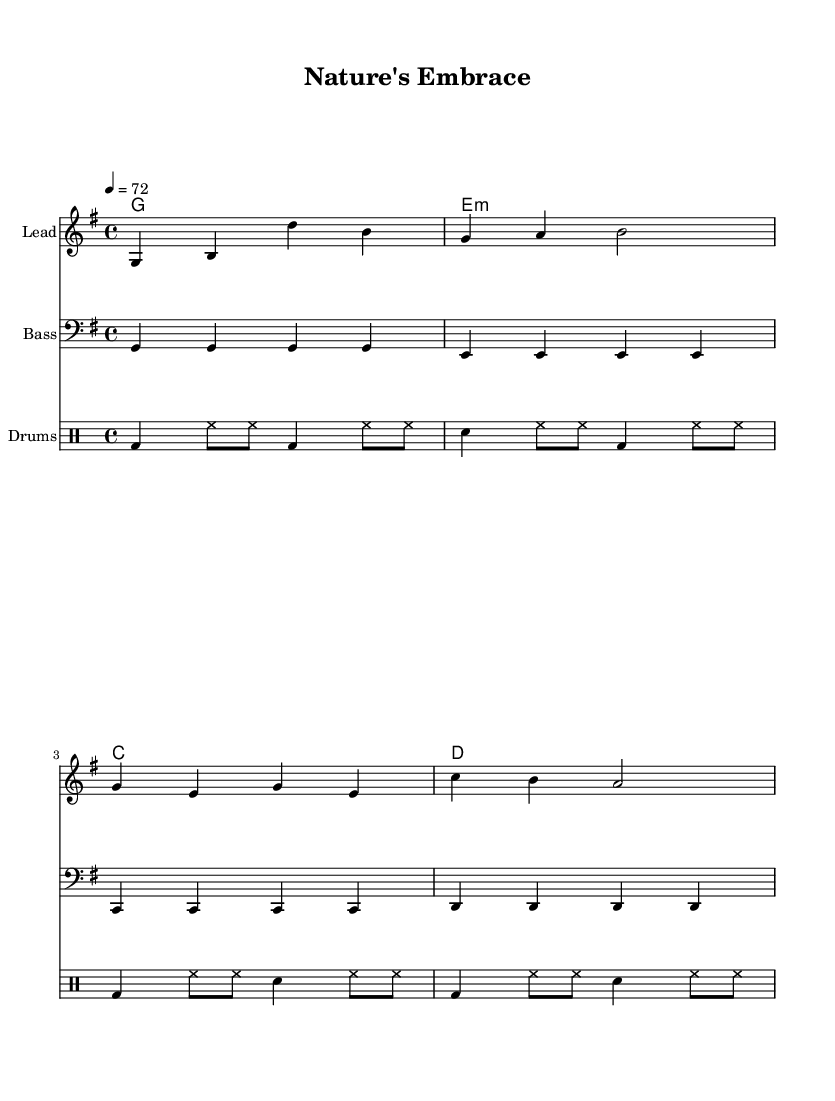What is the key signature of this music? The key signature is G major, which has one sharp (F#). This can be identified by looking at the key signature indicated at the beginning of the staff where the note F has a sharp symbol.
Answer: G major What is the time signature of this piece? The time signature is 4/4, which means there are four beats in each measure and the quarter note gets one beat. This is stated at the beginning of the score where the "4/4" is written.
Answer: 4/4 What is the tempo marking for this piece? The tempo marking is 72 beats per minute. It is indicated at the beginning of the score with the note "4 = 72," meaning a quarter note gets 72 beats in one minute.
Answer: 72 How many measures are in the melody? The melody consists of four measures. This can be counted by looking at the vertical bar lines separating each measure in the melody's notation.
Answer: 4 What chord is played on the first beat of the first measure? The chord played is G major. This is indicated in the chord names section where the first chord listed is "g1," corresponding to G major.
Answer: G major What type of drum pattern is primarily used in this piece? The primary drum pattern is a standard reggae rhythm. This is recognizable by the repetitive bass drum and snare placements, typical of reggae music.
Answer: reggae rhythm 